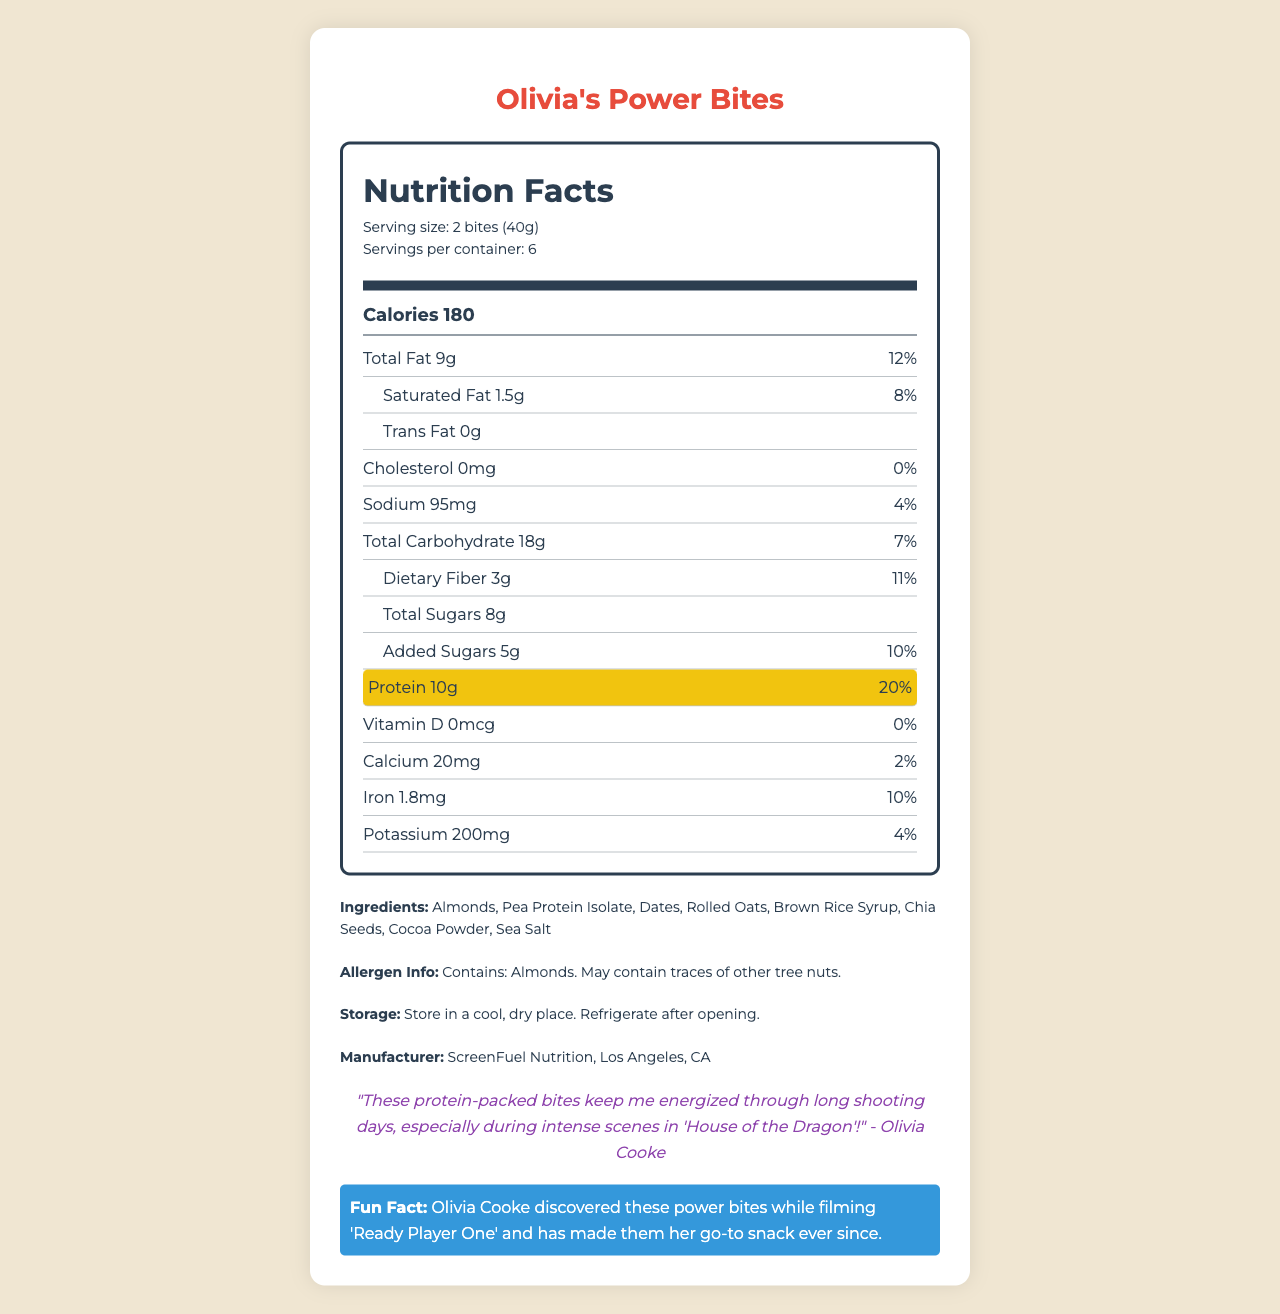what is the serving size of Olivia's Power Bites? The serving size information is provided in the "Nutrition Facts" label under the serving info section.
Answer: 2 bites (40g) how many calories are in one serving of Olivia's Power Bites? The calorie count per serving is displayed prominently in the main info section of the Nutrition Facts label.
Answer: 180 how much protein is in one serving of Olivia's Power Bites? The protein content is highlighted in the Nutrition Facts label and marked as important with a special style.
Answer: 10g what is the daily value percentage for protein in Olivia's Power Bites? The daily value percentage for protein is listed next to the amount of protein in the highlighted section.
Answer: 20% which ingredient is the main protein source in Olivia's Power Bites? Pea protein isolate is listed among the ingredients, which is known to be a source of protein.
Answer: Pea Protein Isolate what is the total fat content per serving of Olivia's Power Bites? The total fat content per serving is listed under the nutrient rows in the Nutrition Facts label.
Answer: 9g does Olivia's Power Bites contain any added sugars? The document specifies "Added Sugars 5g" and provides the daily value percentage for it.
Answer: Yes which nutrient has the highest daily value percentage in Olivia's Power Bites? A. Total Fat B. Dietary Fiber C. Protein D. Sodium The protein content in one serving provides 20% of the daily value, which is the highest percentage among listed nutrients.
Answer: C. Protein how much sodium is in one serving of Olivia's Power Bites? The sodium amount is listed under the nutrient information in the Nutrition Facts label.
Answer: 95mg Olivia Cooke discovered these power bites while filming which movie? The fun fact at the bottom of the document mentions that Olivia Cooke discovered these power bites while filming 'Ready Player One.'
Answer: Ready Player One what is the manufacturer's name and location? The document provides the manufacturer's details in the section under the ingredients and storage instructions.
Answer: ScreenFuel Nutrition, Los Angeles, CA are Olivia's Power Bites suitable for individuals allergic to tree nuts? The allergen information states that the product contains almonds and may contain traces of other tree nuts.
Answer: No how should Olivia's Power Bites be stored after opening? The storage instructions specify to store in a cool, dry place and refrigerate after opening.
Answer: Refrigerate after opening what is the total carbohydrate content including dietary fiber and total sugars? The total carbohydrate content is listed in the nutrient rows of the Nutrition Facts label.
Answer: 18g based on the document, what is Olivia Cooke's opinion about Olivia's Power Bites? Olivia's quote reflects her opinion, mentioning that the bites help her stay energized especially during intense scenes.
Answer: "These protein-packed bites keep me energized through long shooting days, especially during intense scenes in 'House of the Dragon'!" summarize the main idea of the document. The document provides detailed information about Olivia's Power Bites, including their nutritional content, ingredients, storage instructions, and a personal endorsement from Olivia Cooke.
Answer: Olivia's Power Bites are a high-protein, nutrient-dense on-set snack favored by Olivia Cooke. The document features its nutrition facts, ingredients, allergens, and a quote from Olivia highlighting its benefits during her filming schedules. how much vitamin D is in a serving of Olivia's Power Bites? The amount of vitamin D is listed as 0mcg in the nutrient rows of the Nutrition Facts label.
Answer: 0mcg do Olivia's Power Bites contain cocoa powder? Cocoa powder is listed among the ingredients in the document.
Answer: Yes is there any cholesterol in Olivia's Power Bites? The document specifies that the cholesterol content is 0mg in the nutrient rows.
Answer: No where did Olivia Cooke discover these power bites? While the fun fact mentions she discovered them while filming 'Ready Player One,' the specific location of the discovery is not provided.
Answer: Cannot be determined 